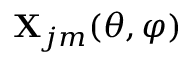Convert formula to latex. <formula><loc_0><loc_0><loc_500><loc_500>X _ { j m } ( \theta , \varphi )</formula> 